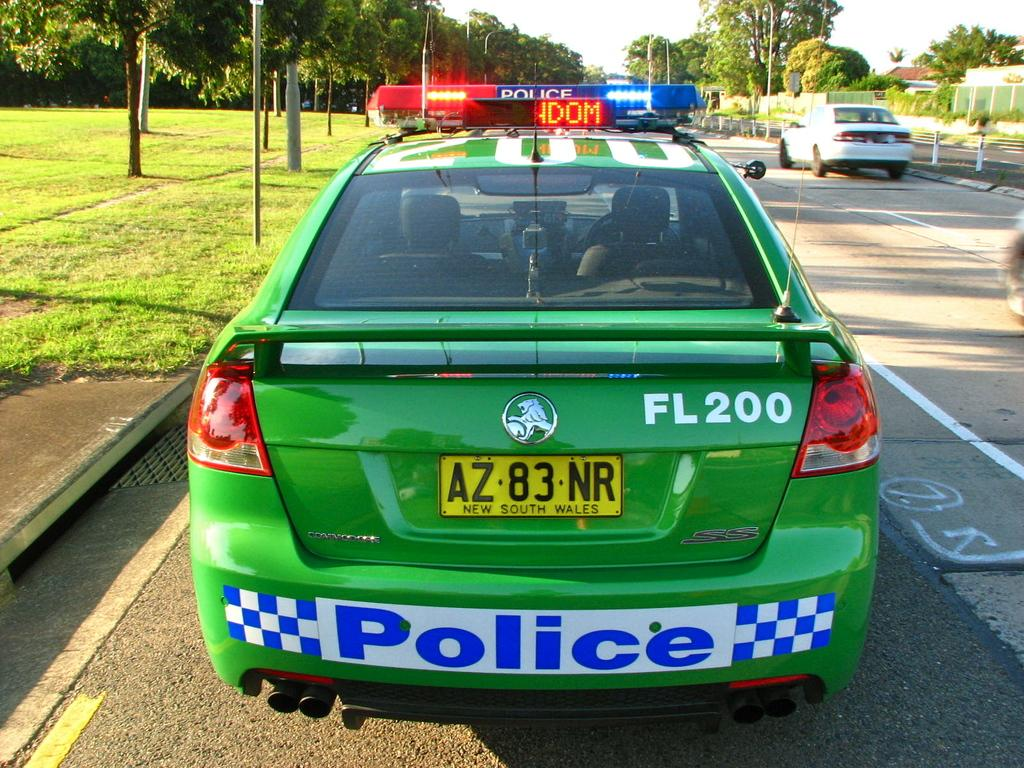What type of vehicles can be seen on the road in the image? There are motor vehicles on the road in the image. What structures are present along the road? Street poles and buildings are visible in the image. What lighting is provided in the image? Street lights are visible in the image. What type of vegetation can be seen in the image? Trees and grass are present in the image. What part of the natural environment is visible in the image? The sky is visible in the image. What is the opinion of the cent in the image? There is no cent present in the image, and therefore no opinion can be attributed to it. How does the image show respect for the environment? The image does not explicitly show respect for the environment; it simply depicts a scene with various elements, including trees, grass, and the sky. 